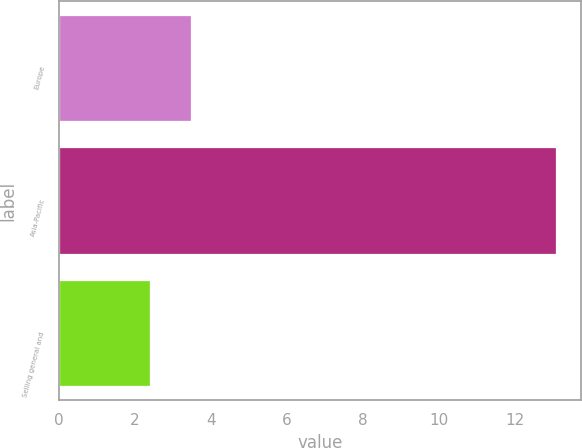<chart> <loc_0><loc_0><loc_500><loc_500><bar_chart><fcel>Europe<fcel>Asia-Pacific<fcel>Selling general and<nl><fcel>3.47<fcel>13.1<fcel>2.4<nl></chart> 